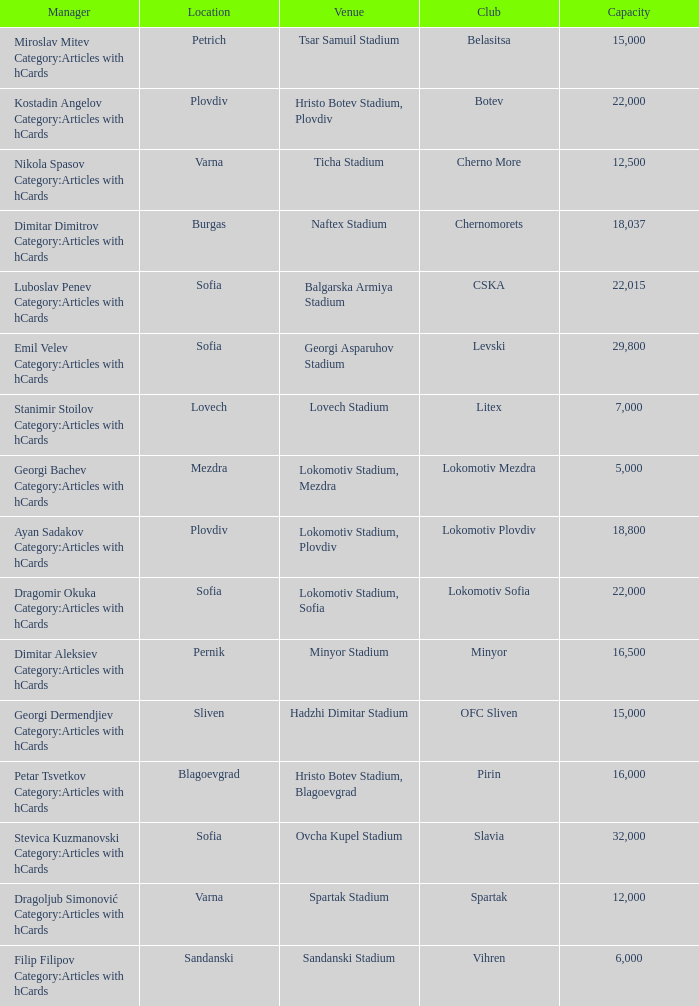What is the highest capacity for the venue of the club, vihren? 6000.0. 